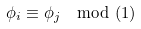<formula> <loc_0><loc_0><loc_500><loc_500>\phi _ { i } \equiv \phi _ { j } \mod ( 1 )</formula> 